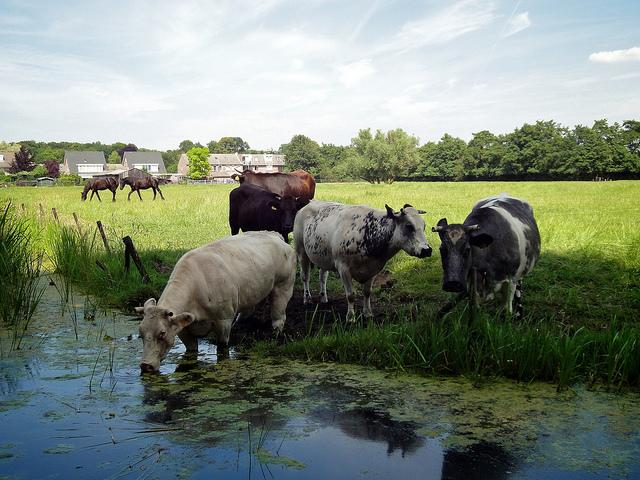Why does the animal have its head to the water?

Choices:
A) to spit
B) to drink
C) to swim
D) to dive to drink 